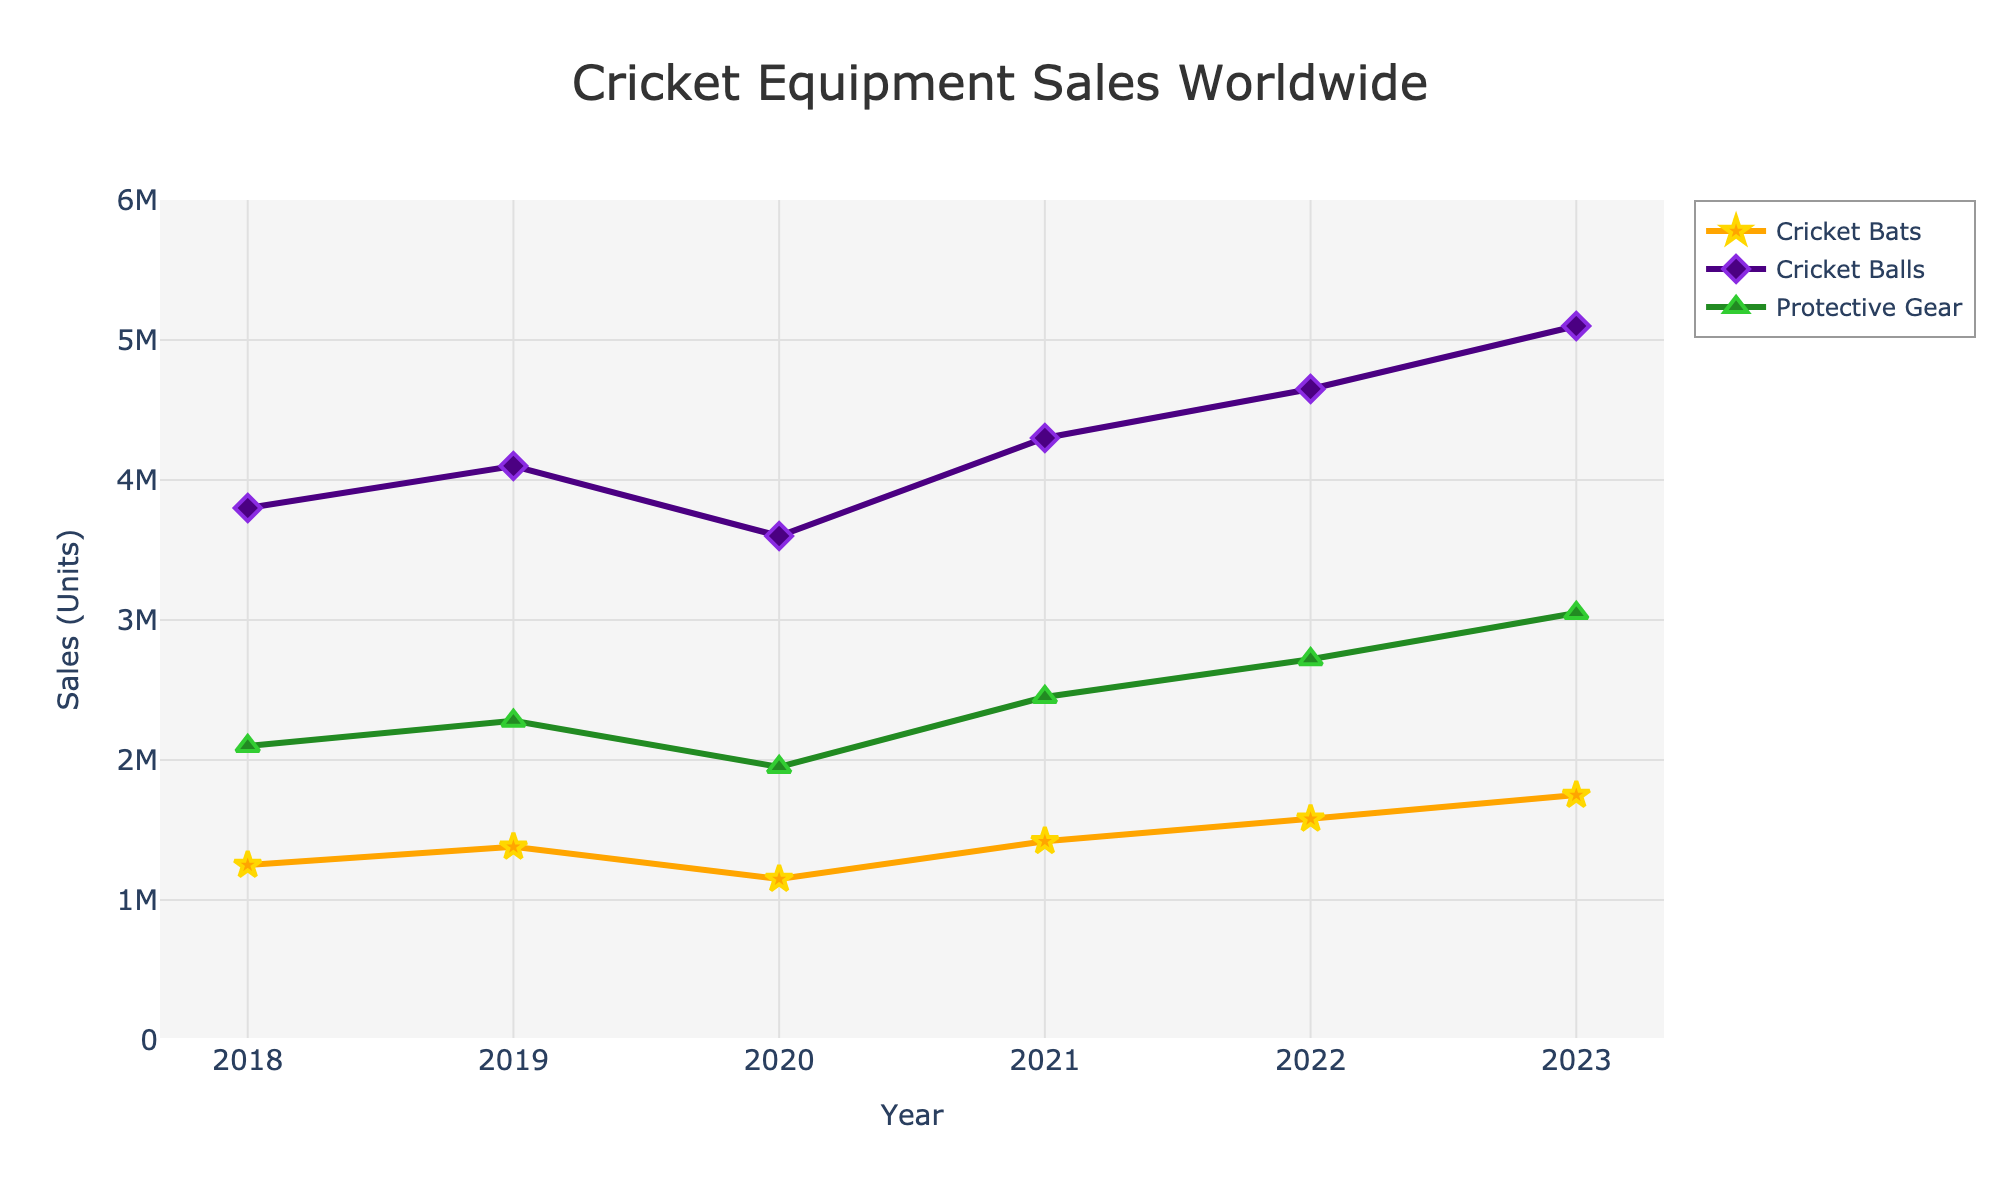What is the trend in sales figures for cricket bats between 2018 and 2023? By examining the orange line representing cricket bats, we see a consistent upward trend in sales from 2018, with only a dip in 2020. Overall, sales increase each year from 1,250,000 units in 2018 to 1,750,000 units in 2023.
Answer: Increasing trend In which year do cricket balls have the highest sales, and what is the total sales figure for that year? The purple line representing cricket balls peaks in 2023. The total sales figure for cricket balls in that year is 5,100,000 units.
Answer: 2023, 5,100,000 units Compare the sales of protective gear in 2019 and 2022. Which year had higher sales and by how much? Protective gear sales in 2019 were 2,280,000 units, and in 2022 they were 2,720,000 units. The difference between 2022 and 2019 is 2,720,000 - 2,280,000 = 440,000 units.
Answer: 2022, 440,000 units more What percentage increase in sales do cricket balls show from 2018 to 2023? First, find the sales in 2018 (3,800,000 units) and in 2023 (5,100,000 units). The increase is 5,100,000 - 3,800,000 = 1,300,000 units. The percentage increase is (1,300,000 / 3,800,000) * 100 ≈ 34.21%.
Answer: 34.21% Which product category shows the most significant sales decline in any year within 2018-2023, and what is the amount of that decline? Comparing the annual changes, cricket bats show the most significant sales decline in 2020 with a drop from 1,380,000 units in 2019 to 1,150,000 units in 2020, a decline of 1,380,000 - 1,150,000 = 230,000 units.
Answer: Cricket bats, 230,000 units What is the average annual sales of protective gear between 2018 and 2023? Sum the total sales across the years for protective gear (2,100,000 + 2,280,000 + 1,950,000 + 2,450,000 + 2,720,000 + 3,050,000), which equals 14,550,000. Divide by the number of years (6) to get the average: 14,550,000 / 6 ≈ 2,425,000 units.
Answer: 2,425,000 units In which year did sales of cricket equipment (sum of all categories) reach the highest point? Add the sales for each category in each year. 2023 has the highest total: 1,750,000 (bats) + 5,100,000 (balls) + 3,050,000 (gear) = 9,900,000 units.
Answer: 2023 How do the sales figures for cricket balls compare visually to other categories on the chart? The purple line for cricket balls is consistently the highest on the chart, indicating higher sales compared to the orange line for cricket bats and the green line for protective gear throughout the given years.
Answer: Highest sales What was the overall trend in the sales of protective gear, and how significant was its growth from 2018 to 2023? The green line for protective gear shows a general upward trend without any declines. The growth from 2018 (2,100,000 units) to 2023 (3,050,000 units) is 3,050,000 - 2,100,000 = 950,000 units.
Answer: Upward trend, 950,000 units During which years did cricket bats experience a noticeable decline in sales, and what was the reason for this from a data perspective? The orange line for cricket bats shows a decline in 2020, dropping from 1,380,000 units in 2019 to 1,150,000 units. This decline could be due to external factors such as changes in market demand or disruptions.
Answer: 2020, external factors 